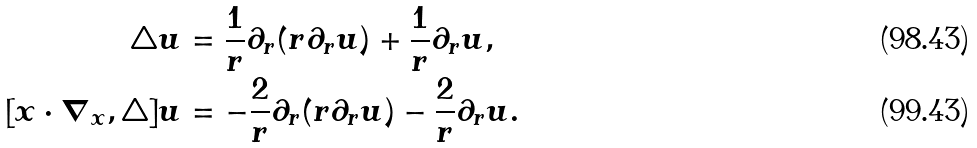<formula> <loc_0><loc_0><loc_500><loc_500>\triangle u & = \frac { 1 } { r } \partial _ { r } ( r \partial _ { r } u ) + \frac { 1 } { r } \partial _ { r } u , \\ [ x \cdot \nabla _ { x } , \triangle ] u & = - \frac { 2 } { r } \partial _ { r } ( r \partial _ { r } u ) - \frac { 2 } { r } \partial _ { r } u .</formula> 